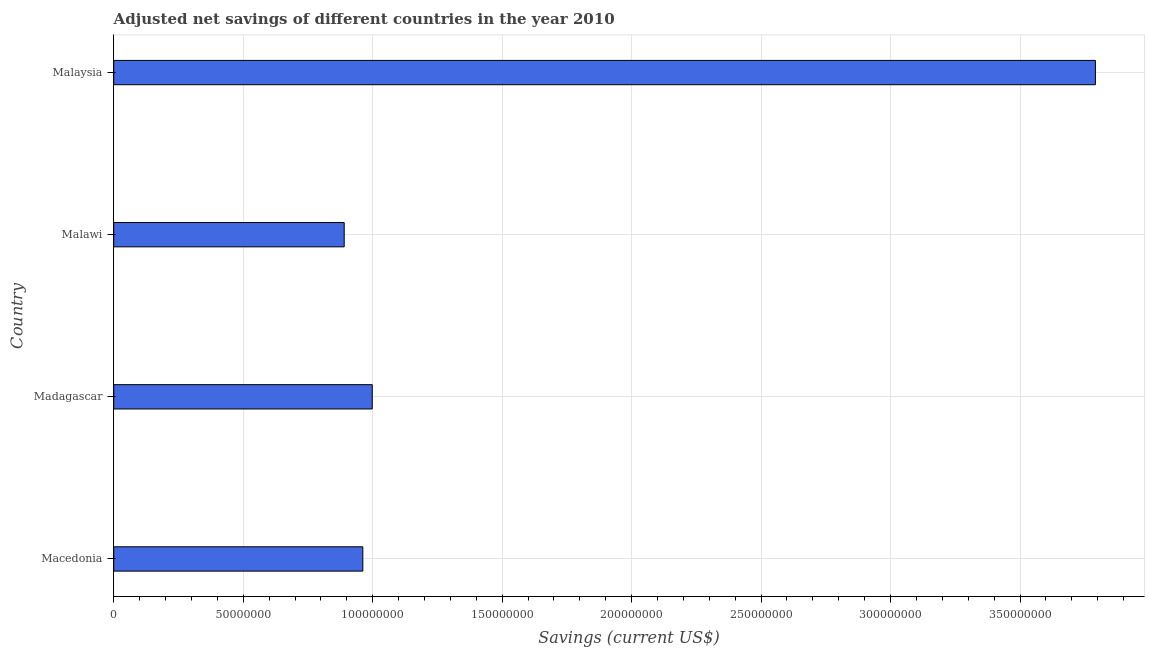Does the graph contain any zero values?
Offer a terse response. No. Does the graph contain grids?
Your answer should be very brief. Yes. What is the title of the graph?
Give a very brief answer. Adjusted net savings of different countries in the year 2010. What is the label or title of the X-axis?
Ensure brevity in your answer.  Savings (current US$). What is the adjusted net savings in Macedonia?
Your response must be concise. 9.62e+07. Across all countries, what is the maximum adjusted net savings?
Your response must be concise. 3.79e+08. Across all countries, what is the minimum adjusted net savings?
Offer a terse response. 8.90e+07. In which country was the adjusted net savings maximum?
Offer a very short reply. Malaysia. In which country was the adjusted net savings minimum?
Give a very brief answer. Malawi. What is the sum of the adjusted net savings?
Give a very brief answer. 6.64e+08. What is the difference between the adjusted net savings in Madagascar and Malawi?
Keep it short and to the point. 1.08e+07. What is the average adjusted net savings per country?
Make the answer very short. 1.66e+08. What is the median adjusted net savings?
Your answer should be compact. 9.80e+07. In how many countries, is the adjusted net savings greater than 10000000 US$?
Your response must be concise. 4. What is the ratio of the adjusted net savings in Madagascar to that in Malaysia?
Provide a succinct answer. 0.26. Is the difference between the adjusted net savings in Macedonia and Madagascar greater than the difference between any two countries?
Your answer should be very brief. No. What is the difference between the highest and the second highest adjusted net savings?
Make the answer very short. 2.79e+08. What is the difference between the highest and the lowest adjusted net savings?
Your answer should be compact. 2.90e+08. How many bars are there?
Your answer should be compact. 4. Are all the bars in the graph horizontal?
Provide a succinct answer. Yes. Are the values on the major ticks of X-axis written in scientific E-notation?
Provide a short and direct response. No. What is the Savings (current US$) of Macedonia?
Ensure brevity in your answer.  9.62e+07. What is the Savings (current US$) of Madagascar?
Ensure brevity in your answer.  9.98e+07. What is the Savings (current US$) in Malawi?
Offer a very short reply. 8.90e+07. What is the Savings (current US$) of Malaysia?
Give a very brief answer. 3.79e+08. What is the difference between the Savings (current US$) in Macedonia and Madagascar?
Keep it short and to the point. -3.64e+06. What is the difference between the Savings (current US$) in Macedonia and Malawi?
Your answer should be compact. 7.19e+06. What is the difference between the Savings (current US$) in Macedonia and Malaysia?
Your answer should be very brief. -2.83e+08. What is the difference between the Savings (current US$) in Madagascar and Malawi?
Offer a very short reply. 1.08e+07. What is the difference between the Savings (current US$) in Madagascar and Malaysia?
Your answer should be very brief. -2.79e+08. What is the difference between the Savings (current US$) in Malawi and Malaysia?
Make the answer very short. -2.90e+08. What is the ratio of the Savings (current US$) in Macedonia to that in Malawi?
Ensure brevity in your answer.  1.08. What is the ratio of the Savings (current US$) in Macedonia to that in Malaysia?
Your answer should be compact. 0.25. What is the ratio of the Savings (current US$) in Madagascar to that in Malawi?
Your response must be concise. 1.12. What is the ratio of the Savings (current US$) in Madagascar to that in Malaysia?
Ensure brevity in your answer.  0.26. What is the ratio of the Savings (current US$) in Malawi to that in Malaysia?
Provide a short and direct response. 0.23. 